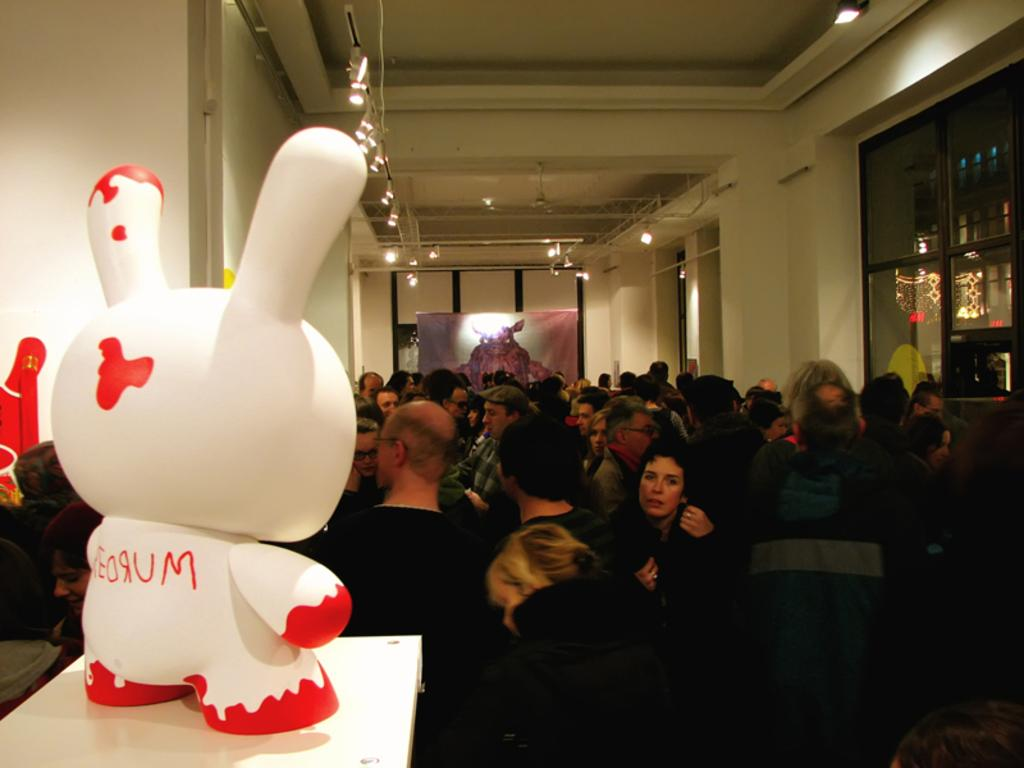What is on the floor in the image? There is a crowd on the floor in the image. What is on a table in the image? There is a doll on a table in the image. What can be seen in the background of the image? There is a wall, lights, a window, a poster, and shelves in the background of the image. Where was the image taken? The image was taken in a hall. What type of heart is visible on the doll in the image? There is no heart visible on the doll in the image. What is the thing that the crowd is using to eat the doll in the image? The crowd is not eating the doll, and there is no spoon or any other utensil visible in the image. 